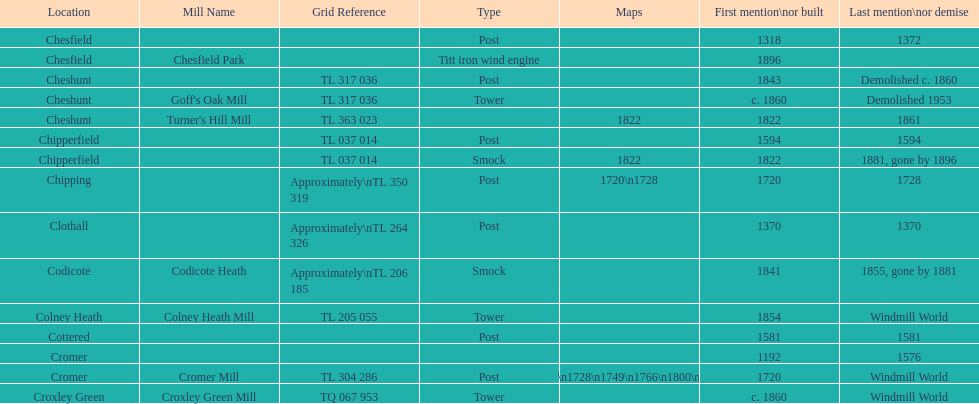How many locations have no photograph? 14. 